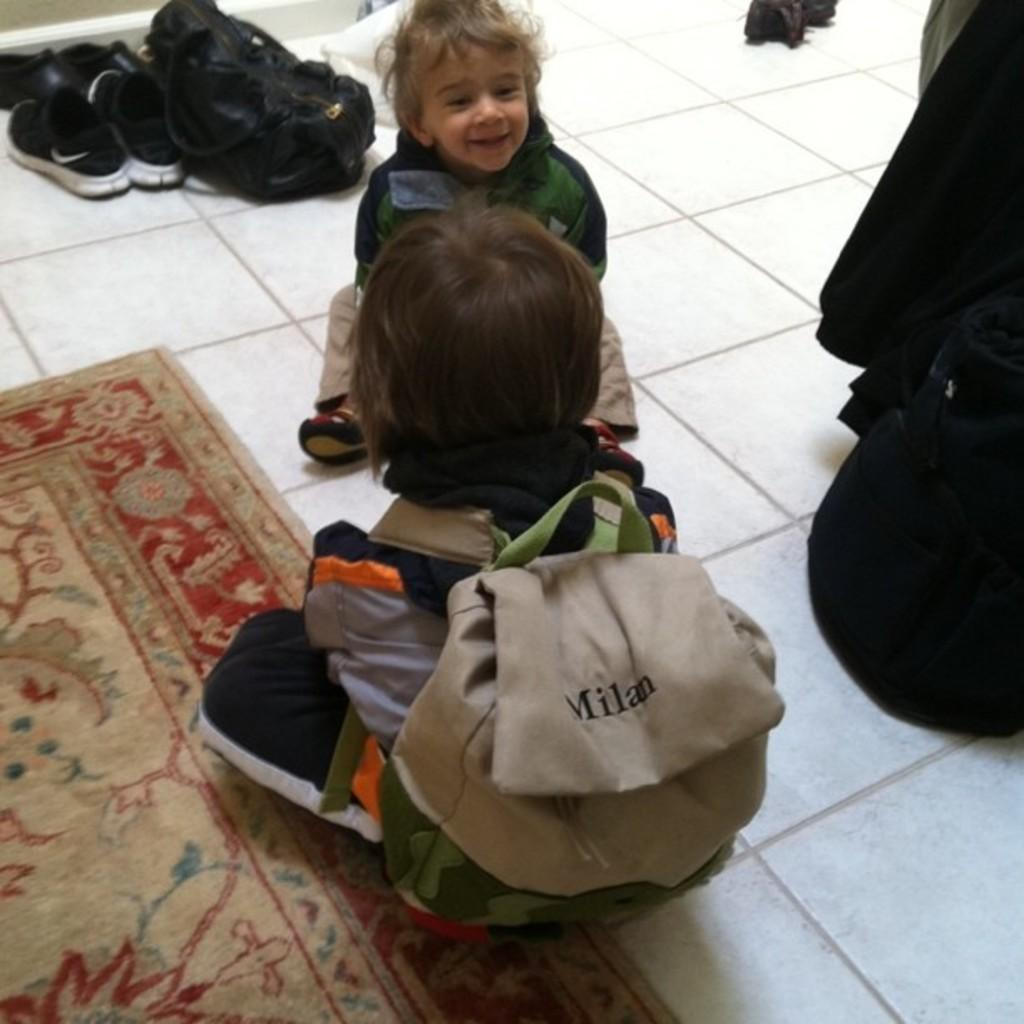<image>
Describe the image concisely. the child is wearing a backpack that is labeled Milan 